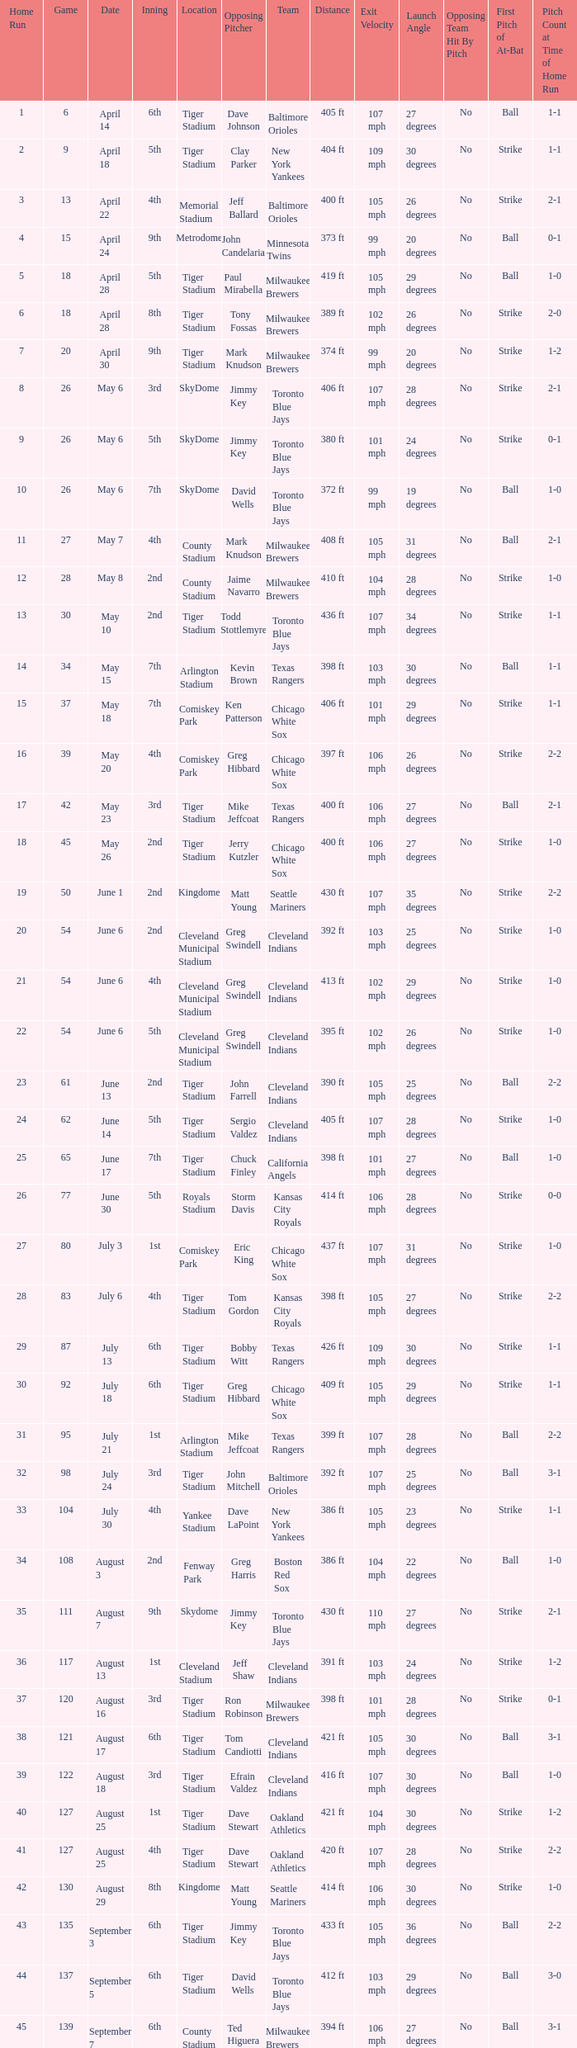Give me the full table as a dictionary. {'header': ['Home Run', 'Game', 'Date', 'Inning', 'Location', 'Opposing Pitcher', 'Team', 'Distance', 'Exit Velocity', 'Launch Angle', 'Opposing Team Hit By Pitch', 'First Pitch of At-Bat', 'Pitch Count at Time of Home Run'], 'rows': [['1', '6', 'April 14', '6th', 'Tiger Stadium', 'Dave Johnson', 'Baltimore Orioles', '405 ft', '107 mph', '27 degrees', 'No', 'Ball', '1-1'], ['2', '9', 'April 18', '5th', 'Tiger Stadium', 'Clay Parker', 'New York Yankees', '404 ft', '109 mph', '30 degrees', 'No', 'Strike', '1-1'], ['3', '13', 'April 22', '4th', 'Memorial Stadium', 'Jeff Ballard', 'Baltimore Orioles', '400 ft', '105 mph', '26 degrees', 'No', 'Strike', '2-1'], ['4', '15', 'April 24', '9th', 'Metrodome', 'John Candelaria', 'Minnesota Twins', '373 ft', '99 mph', '20 degrees', 'No', 'Ball', '0-1'], ['5', '18', 'April 28', '5th', 'Tiger Stadium', 'Paul Mirabella', 'Milwaukee Brewers', '419 ft', '105 mph', '29 degrees', 'No', 'Ball', '1-0'], ['6', '18', 'April 28', '8th', 'Tiger Stadium', 'Tony Fossas', 'Milwaukee Brewers', '389 ft', '102 mph', '26 degrees', 'No', 'Strike', '2-0'], ['7', '20', 'April 30', '9th', 'Tiger Stadium', 'Mark Knudson', 'Milwaukee Brewers', '374 ft', '99 mph', '20 degrees', 'No', 'Strike', '1-2'], ['8', '26', 'May 6', '3rd', 'SkyDome', 'Jimmy Key', 'Toronto Blue Jays', '406 ft', '107 mph', '28 degrees', 'No', 'Strike', '2-1'], ['9', '26', 'May 6', '5th', 'SkyDome', 'Jimmy Key', 'Toronto Blue Jays', '380 ft', '101 mph', '24 degrees', 'No', 'Strike', '0-1'], ['10', '26', 'May 6', '7th', 'SkyDome', 'David Wells', 'Toronto Blue Jays', '372 ft', '99 mph', '19 degrees', 'No', 'Ball', '1-0'], ['11', '27', 'May 7', '4th', 'County Stadium', 'Mark Knudson', 'Milwaukee Brewers', '408 ft', '105 mph', '31 degrees', 'No', 'Ball', '2-1'], ['12', '28', 'May 8', '2nd', 'County Stadium', 'Jaime Navarro', 'Milwaukee Brewers', '410 ft', '104 mph', '28 degrees', 'No', 'Strike', '1-0'], ['13', '30', 'May 10', '2nd', 'Tiger Stadium', 'Todd Stottlemyre', 'Toronto Blue Jays', '436 ft', '107 mph', '34 degrees', 'No', 'Strike', '1-1'], ['14', '34', 'May 15', '7th', 'Arlington Stadium', 'Kevin Brown', 'Texas Rangers', '398 ft', '103 mph', '30 degrees', 'No', 'Ball', '1-1'], ['15', '37', 'May 18', '7th', 'Comiskey Park', 'Ken Patterson', 'Chicago White Sox', '406 ft', '101 mph', '29 degrees', 'No', 'Strike', '1-1'], ['16', '39', 'May 20', '4th', 'Comiskey Park', 'Greg Hibbard', 'Chicago White Sox', '397 ft', '106 mph', '26 degrees', 'No', 'Strike', '2-2'], ['17', '42', 'May 23', '3rd', 'Tiger Stadium', 'Mike Jeffcoat', 'Texas Rangers', '400 ft', '106 mph', '27 degrees', 'No', 'Ball', '2-1'], ['18', '45', 'May 26', '2nd', 'Tiger Stadium', 'Jerry Kutzler', 'Chicago White Sox', '400 ft', '106 mph', '27 degrees', 'No', 'Strike', '1-0'], ['19', '50', 'June 1', '2nd', 'Kingdome', 'Matt Young', 'Seattle Mariners', '430 ft', '107 mph', '35 degrees', 'No', 'Strike', '2-2'], ['20', '54', 'June 6', '2nd', 'Cleveland Municipal Stadium', 'Greg Swindell', 'Cleveland Indians', '392 ft', '103 mph', '25 degrees', 'No', 'Strike', '1-0'], ['21', '54', 'June 6', '4th', 'Cleveland Municipal Stadium', 'Greg Swindell', 'Cleveland Indians', '413 ft', '102 mph', '29 degrees', 'No', 'Strike', '1-0'], ['22', '54', 'June 6', '5th', 'Cleveland Municipal Stadium', 'Greg Swindell', 'Cleveland Indians', '395 ft', '102 mph', '26 degrees', 'No', 'Strike', '1-0'], ['23', '61', 'June 13', '2nd', 'Tiger Stadium', 'John Farrell', 'Cleveland Indians', '390 ft', '105 mph', '25 degrees', 'No', 'Ball', '2-2'], ['24', '62', 'June 14', '5th', 'Tiger Stadium', 'Sergio Valdez', 'Cleveland Indians', '405 ft', '107 mph', '28 degrees', 'No', 'Strike', '1-0'], ['25', '65', 'June 17', '7th', 'Tiger Stadium', 'Chuck Finley', 'California Angels', '398 ft', '101 mph', '27 degrees', 'No', 'Ball', '1-0'], ['26', '77', 'June 30', '5th', 'Royals Stadium', 'Storm Davis', 'Kansas City Royals', '414 ft', '106 mph', '28 degrees', 'No', 'Strike', '0-0'], ['27', '80', 'July 3', '1st', 'Comiskey Park', 'Eric King', 'Chicago White Sox', '437 ft', '107 mph', '31 degrees', 'No', 'Strike', '1-0'], ['28', '83', 'July 6', '4th', 'Tiger Stadium', 'Tom Gordon', 'Kansas City Royals', '398 ft', '105 mph', '27 degrees', 'No', 'Strike', '2-2'], ['29', '87', 'July 13', '6th', 'Tiger Stadium', 'Bobby Witt', 'Texas Rangers', '426 ft', '109 mph', '30 degrees', 'No', 'Strike', '1-1'], ['30', '92', 'July 18', '6th', 'Tiger Stadium', 'Greg Hibbard', 'Chicago White Sox', '409 ft', '105 mph', '29 degrees', 'No', 'Strike', '1-1'], ['31', '95', 'July 21', '1st', 'Arlington Stadium', 'Mike Jeffcoat', 'Texas Rangers', '399 ft', '107 mph', '28 degrees', 'No', 'Ball', '2-2'], ['32', '98', 'July 24', '3rd', 'Tiger Stadium', 'John Mitchell', 'Baltimore Orioles', '392 ft', '107 mph', '25 degrees', 'No', 'Ball', '3-1'], ['33', '104', 'July 30', '4th', 'Yankee Stadium', 'Dave LaPoint', 'New York Yankees', '386 ft', '105 mph', '23 degrees', 'No', 'Strike', '1-1'], ['34', '108', 'August 3', '2nd', 'Fenway Park', 'Greg Harris', 'Boston Red Sox', '386 ft', '104 mph', '22 degrees', 'No', 'Ball', '1-0'], ['35', '111', 'August 7', '9th', 'Skydome', 'Jimmy Key', 'Toronto Blue Jays', '430 ft', '110 mph', '27 degrees', 'No', 'Strike', '2-1'], ['36', '117', 'August 13', '1st', 'Cleveland Stadium', 'Jeff Shaw', 'Cleveland Indians', '391 ft', '103 mph', '24 degrees', 'No', 'Strike', '1-2'], ['37', '120', 'August 16', '3rd', 'Tiger Stadium', 'Ron Robinson', 'Milwaukee Brewers', '398 ft', '101 mph', '28 degrees', 'No', 'Strike', '0-1'], ['38', '121', 'August 17', '6th', 'Tiger Stadium', 'Tom Candiotti', 'Cleveland Indians', '421 ft', '105 mph', '30 degrees', 'No', 'Ball', '3-1'], ['39', '122', 'August 18', '3rd', 'Tiger Stadium', 'Efrain Valdez', 'Cleveland Indians', '416 ft', '107 mph', '30 degrees', 'No', 'Ball', '1-0'], ['40', '127', 'August 25', '1st', 'Tiger Stadium', 'Dave Stewart', 'Oakland Athletics', '421 ft', '104 mph', '30 degrees', 'No', 'Strike', '1-2'], ['41', '127', 'August 25', '4th', 'Tiger Stadium', 'Dave Stewart', 'Oakland Athletics', '420 ft', '107 mph', '28 degrees', 'No', 'Strike', '2-2'], ['42', '130', 'August 29', '8th', 'Kingdome', 'Matt Young', 'Seattle Mariners', '414 ft', '106 mph', '30 degrees', 'No', 'Strike', '1-0'], ['43', '135', 'September 3', '6th', 'Tiger Stadium', 'Jimmy Key', 'Toronto Blue Jays', '433 ft', '105 mph', '36 degrees', 'No', 'Ball', '2-2'], ['44', '137', 'September 5', '6th', 'Tiger Stadium', 'David Wells', 'Toronto Blue Jays', '412 ft', '103 mph', '29 degrees', 'No', 'Ball', '3-0'], ['45', '139', 'September 7', '6th', 'County Stadium', 'Ted Higuera', 'Milwaukee Brewers', '394 ft', '106 mph', '27 degrees', 'No', 'Ball', '3-1'], ['46', '145', 'September 13', '9th', 'Tiger Stadium', 'Mike Witt', 'New York Yankees', '419 ft', '108 mph', '28 degrees', 'No', 'Ball', '1-1'], ['47', '148', 'September 16', '5th', 'Tiger Stadium', 'Mark Leiter', 'New York Yankees', '400 ft', '105 mph', '28 degrees', 'No', 'Ball', '2-0'], ['48', '153', 'September 23', '2nd', 'Oakland Coliseum', 'Mike Moore', 'Oakland Athletics', '417 ft', '101 mph', '30 degrees', 'No', 'Strike', '1-0'], ['49', '156', 'September 27', '8th', 'Tiger Stadium', 'Dennis Lamp', 'Boston Red Sox', '390 ft', '103 mph', '25 degrees', 'No', 'Strike', '1-0'], ['50', '162', 'October 3', '4th', 'Yankee Stadium', 'Steve Adkins', 'New York Yankees', '391 ft', '107 mph', '26 degrees', 'No', 'Strike', '1-0'], ['51', '162', 'October 3', '8th', 'Yankee Stadium', 'Alan Mills', 'New York Yankees', '388 ft', '103 mph', '27 degrees', 'No', 'Strike', '0-0']]} When Efrain Valdez was pitching, what was the highest home run? 39.0. 